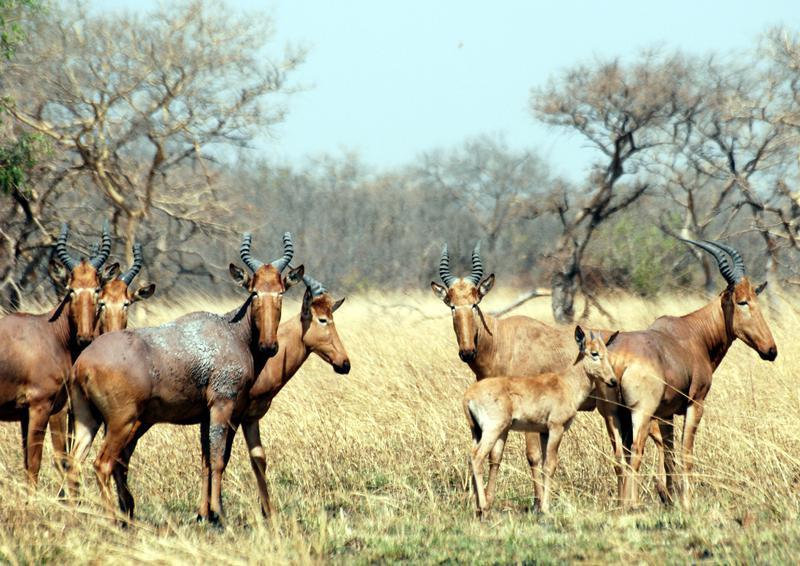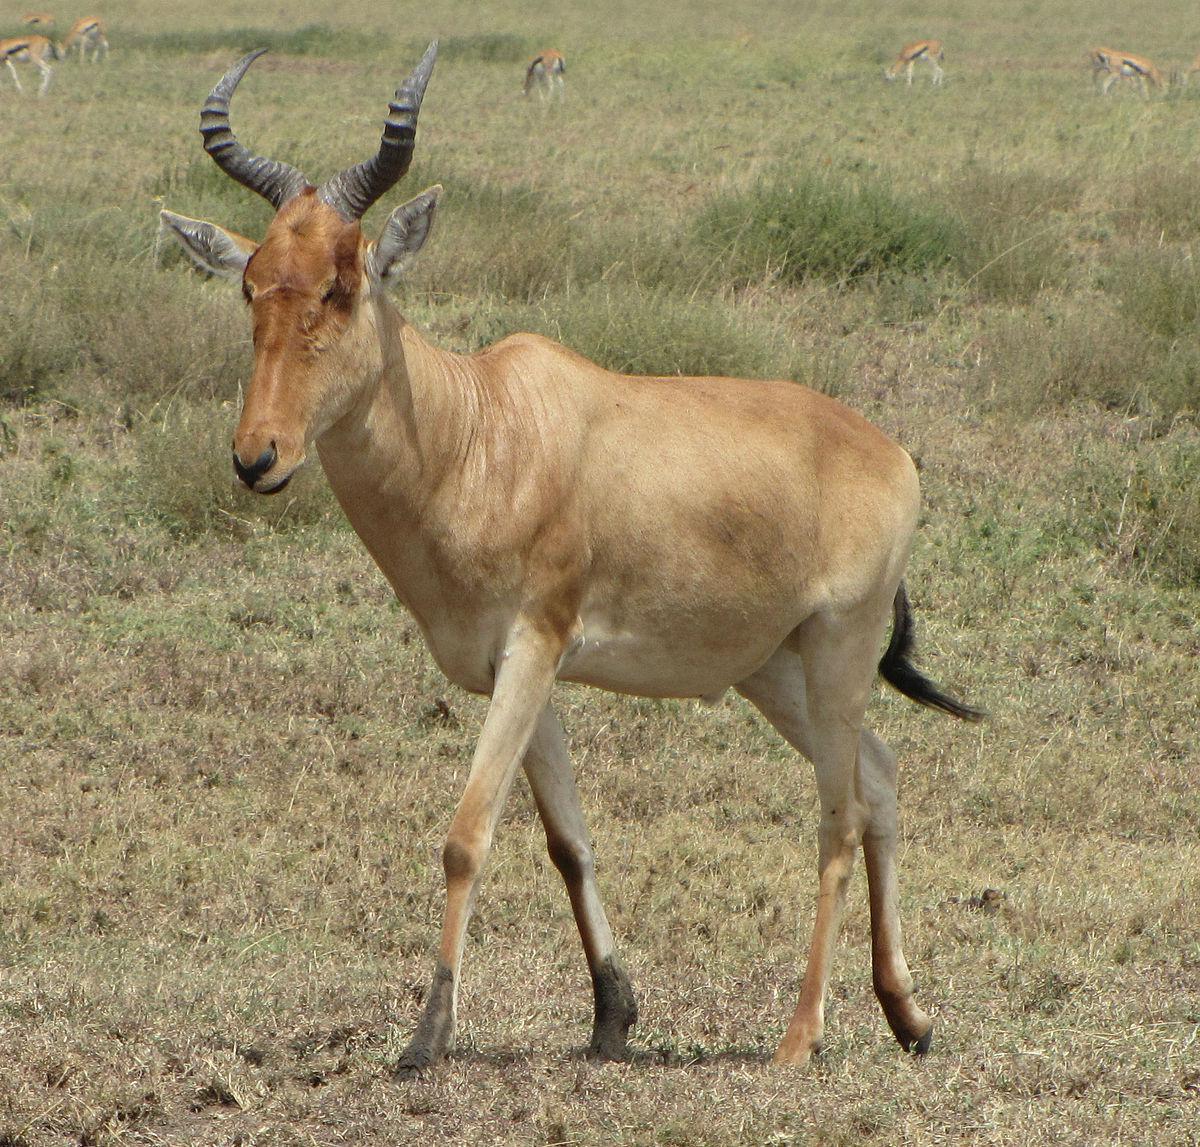The first image is the image on the left, the second image is the image on the right. Evaluate the accuracy of this statement regarding the images: "Only two antelope-type animals are shown, in total.". Is it true? Answer yes or no. No. 